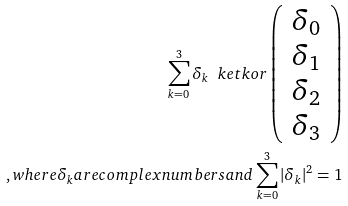<formula> <loc_0><loc_0><loc_500><loc_500>\sum _ { k = 0 } ^ { 3 } { \delta _ { k } \ k e t { k } } o r \left ( \begin{array} { c c c } \delta _ { 0 } \\ \delta _ { 1 } \\ \delta _ { 2 } \\ \delta _ { 3 } \\ \end{array} \right ) \\ , w h e r e \delta _ { k } a r e c o m p l e x n u m b e r s a n d \sum _ { k = 0 } ^ { 3 } { | \delta _ { k } | ^ { 2 } } = 1</formula> 